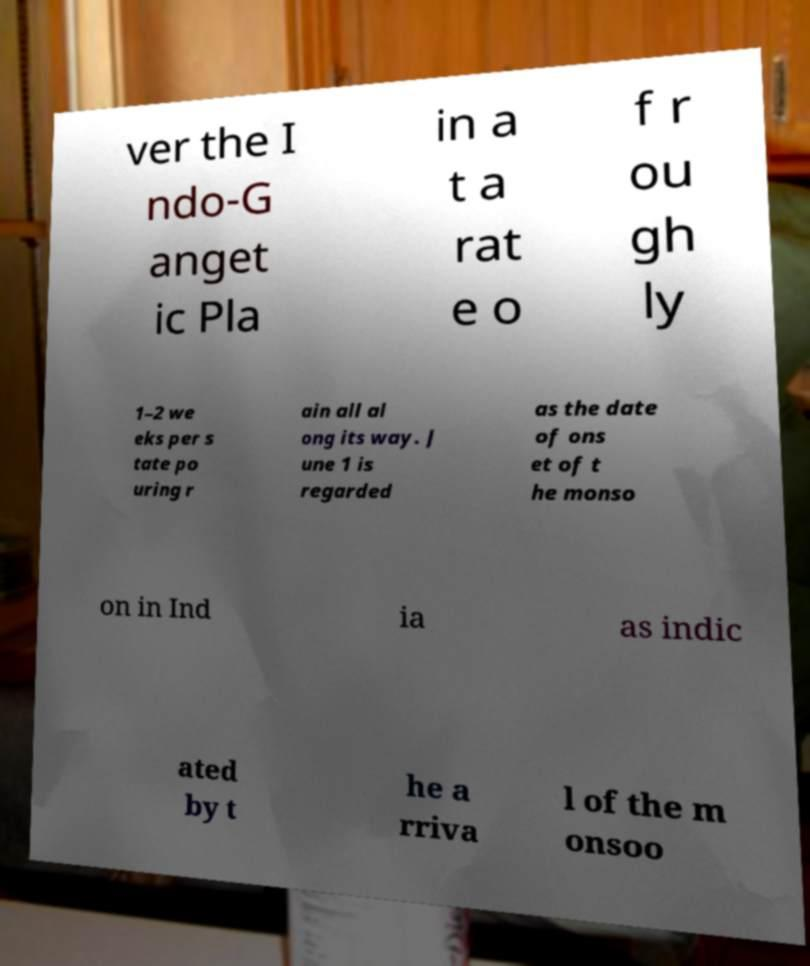Please read and relay the text visible in this image. What does it say? ver the I ndo-G anget ic Pla in a t a rat e o f r ou gh ly 1–2 we eks per s tate po uring r ain all al ong its way. J une 1 is regarded as the date of ons et of t he monso on in Ind ia as indic ated by t he a rriva l of the m onsoo 